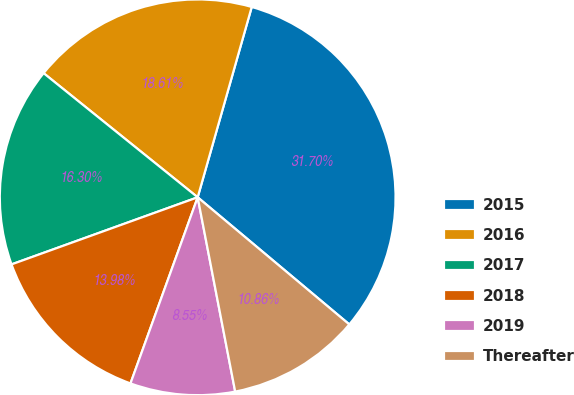<chart> <loc_0><loc_0><loc_500><loc_500><pie_chart><fcel>2015<fcel>2016<fcel>2017<fcel>2018<fcel>2019<fcel>Thereafter<nl><fcel>31.7%<fcel>18.61%<fcel>16.3%<fcel>13.98%<fcel>8.55%<fcel>10.86%<nl></chart> 